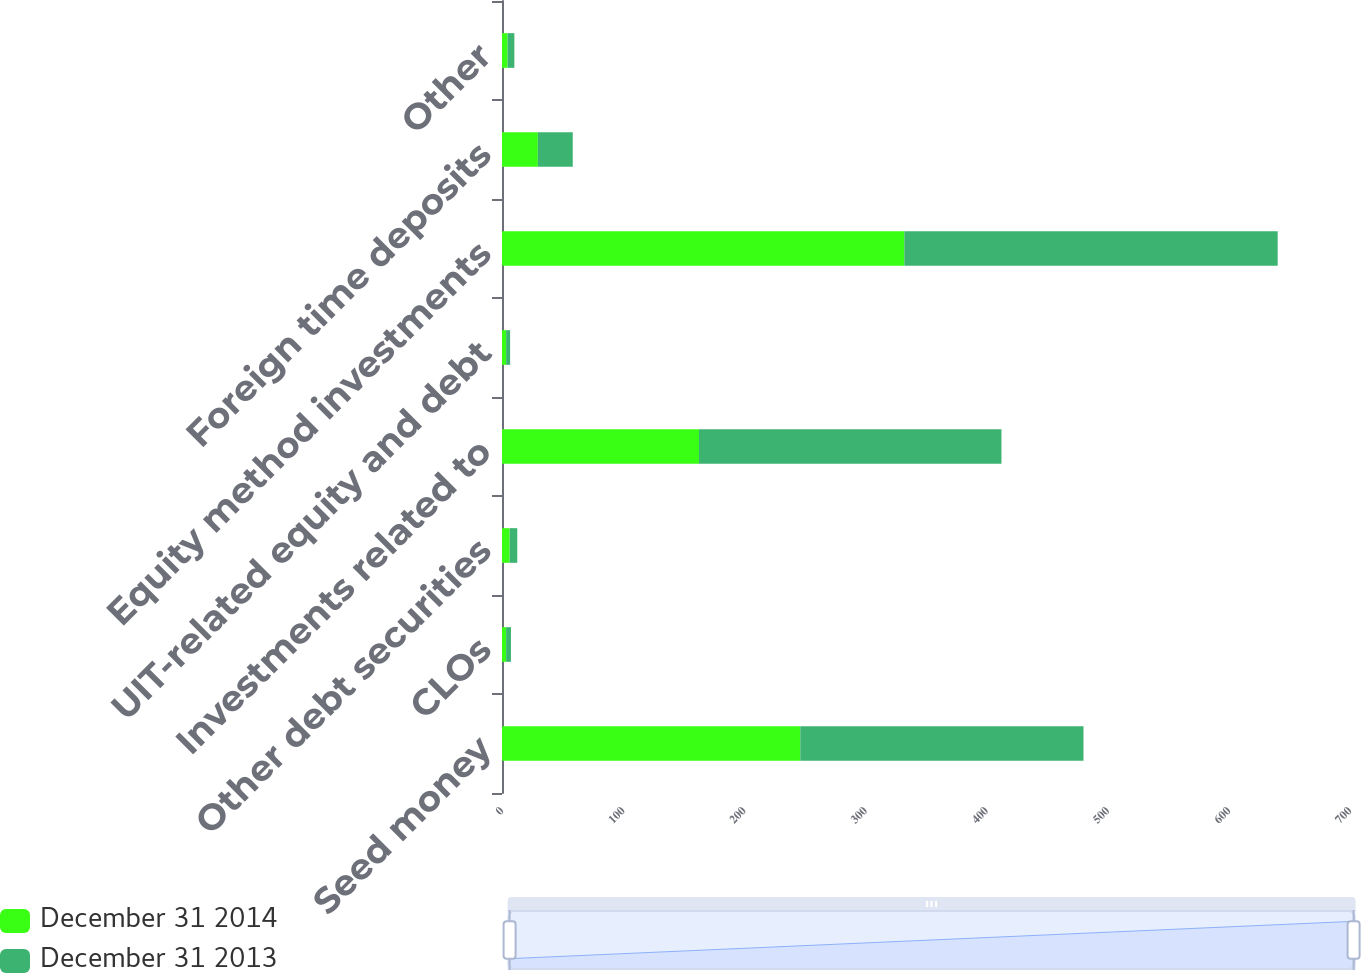<chart> <loc_0><loc_0><loc_500><loc_500><stacked_bar_chart><ecel><fcel>Seed money<fcel>CLOs<fcel>Other debt securities<fcel>Investments related to<fcel>UIT-related equity and debt<fcel>Equity method investments<fcel>Foreign time deposits<fcel>Other<nl><fcel>December 31 2014<fcel>246.2<fcel>3.4<fcel>6.3<fcel>162.6<fcel>3.4<fcel>332.1<fcel>29.6<fcel>4.6<nl><fcel>December 31 2013<fcel>233.8<fcel>4<fcel>6.3<fcel>249.7<fcel>3.3<fcel>308.2<fcel>28.8<fcel>5.6<nl></chart> 